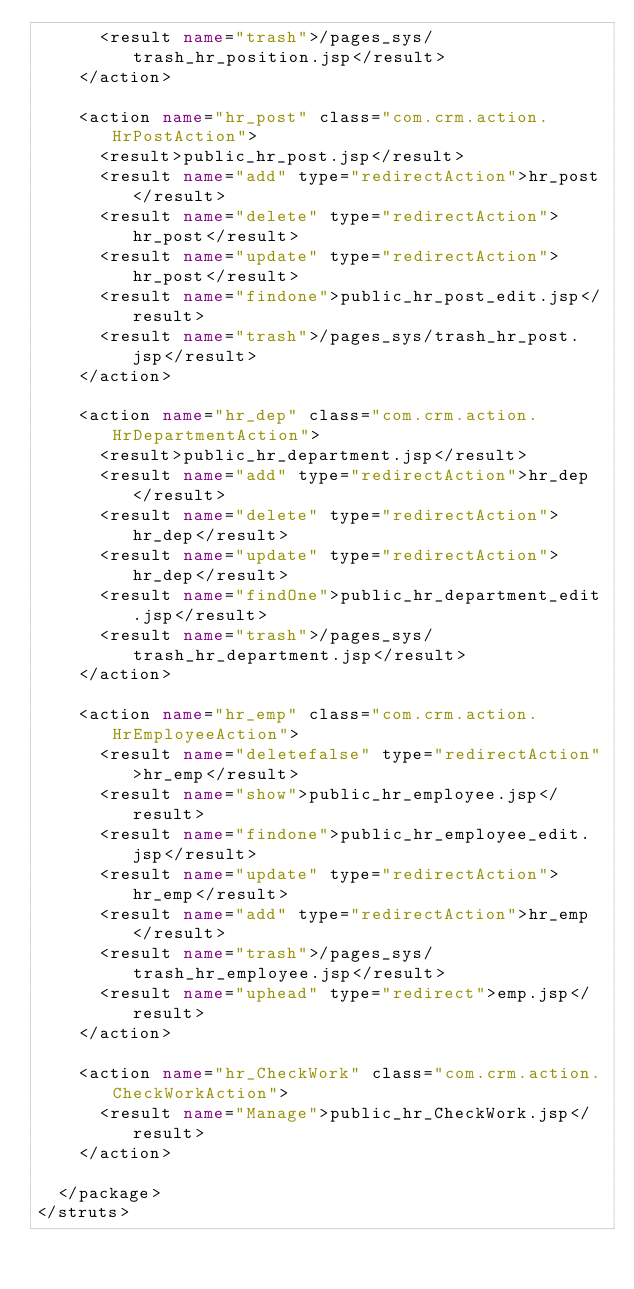Convert code to text. <code><loc_0><loc_0><loc_500><loc_500><_XML_>			<result name="trash">/pages_sys/trash_hr_position.jsp</result>
		</action>
		
		<action name="hr_post" class="com.crm.action.HrPostAction">
			<result>public_hr_post.jsp</result>
			<result name="add" type="redirectAction">hr_post</result>
			<result name="delete" type="redirectAction">hr_post</result>
			<result name="update" type="redirectAction">hr_post</result>
			<result name="findone">public_hr_post_edit.jsp</result>
			<result name="trash">/pages_sys/trash_hr_post.jsp</result>
		</action>

		<action name="hr_dep" class="com.crm.action.HrDepartmentAction">
			<result>public_hr_department.jsp</result>
			<result name="add" type="redirectAction">hr_dep</result>
			<result name="delete" type="redirectAction">hr_dep</result>
			<result name="update" type="redirectAction">hr_dep</result>
			<result name="findOne">public_hr_department_edit.jsp</result>
			<result name="trash">/pages_sys/trash_hr_department.jsp</result>
		</action>

		<action name="hr_emp" class="com.crm.action.HrEmployeeAction">	
			<result name="deletefalse" type="redirectAction">hr_emp</result>
			<result name="show">public_hr_employee.jsp</result>
			<result name="findone">public_hr_employee_edit.jsp</result>
			<result name="update" type="redirectAction">hr_emp</result>
			<result name="add" type="redirectAction">hr_emp</result>
			<result name="trash">/pages_sys/trash_hr_employee.jsp</result>
			<result name="uphead" type="redirect">emp.jsp</result>
		</action>
		
		<action name="hr_CheckWork" class="com.crm.action.CheckWorkAction">
			<result name="Manage">public_hr_CheckWork.jsp</result>
		</action>
		
	</package>
</struts></code> 